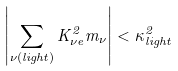Convert formula to latex. <formula><loc_0><loc_0><loc_500><loc_500>\left | \sum _ { \nu ( l i g h t ) } K _ { \nu e } ^ { 2 } m _ { \nu } \right | < \kappa ^ { 2 } _ { l i g h t }</formula> 